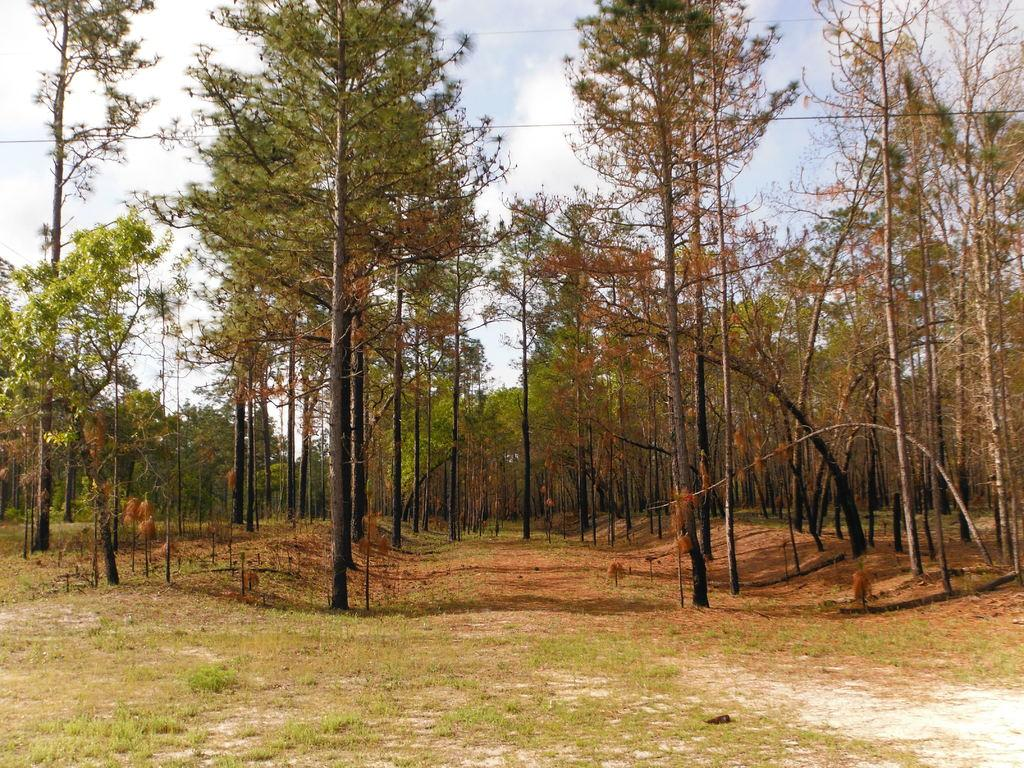What type of vegetation is present in the image? There is a group of trees and grass in the image. What else can be seen in the image besides vegetation? There are wires in the image. What is visible in the background of the image? The sky is visible in the image. How would you describe the sky in the image? The sky appears cloudy in the image. What type of pies are being baked by the trees in the image? There are no pies or baking activity present in the image; it features a group of trees, grass, wires, and a cloudy sky. 